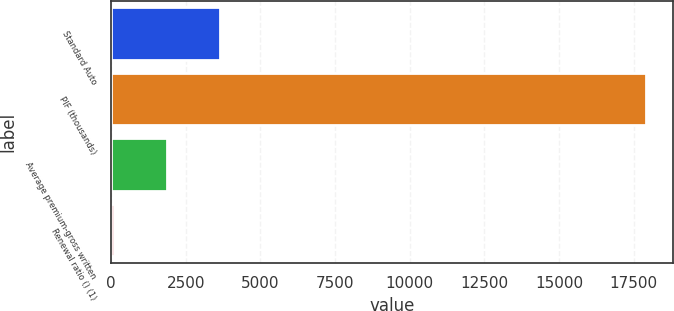Convert chart. <chart><loc_0><loc_0><loc_500><loc_500><bar_chart><fcel>Standard Auto<fcel>PIF (thousands)<fcel>Average premium-gross written<fcel>Renewal ratio () (1)<nl><fcel>3655.92<fcel>17924<fcel>1872.41<fcel>88.9<nl></chart> 